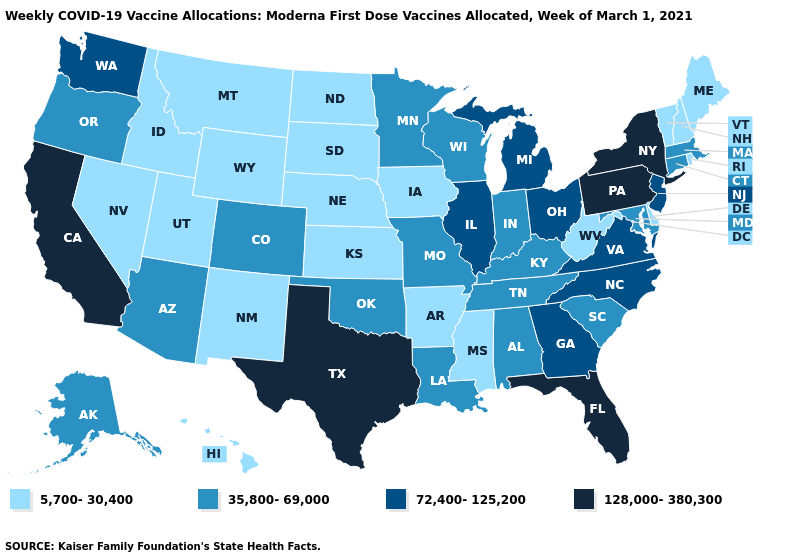What is the value of New York?
Short answer required. 128,000-380,300. What is the value of Rhode Island?
Concise answer only. 5,700-30,400. Does New Jersey have the same value as Washington?
Write a very short answer. Yes. What is the value of Ohio?
Give a very brief answer. 72,400-125,200. Which states have the lowest value in the USA?
Answer briefly. Arkansas, Delaware, Hawaii, Idaho, Iowa, Kansas, Maine, Mississippi, Montana, Nebraska, Nevada, New Hampshire, New Mexico, North Dakota, Rhode Island, South Dakota, Utah, Vermont, West Virginia, Wyoming. Does Pennsylvania have the highest value in the Northeast?
Quick response, please. Yes. Which states hav the highest value in the South?
Write a very short answer. Florida, Texas. What is the value of California?
Concise answer only. 128,000-380,300. Name the states that have a value in the range 72,400-125,200?
Give a very brief answer. Georgia, Illinois, Michigan, New Jersey, North Carolina, Ohio, Virginia, Washington. What is the highest value in the Northeast ?
Write a very short answer. 128,000-380,300. Does North Carolina have the same value as Wyoming?
Answer briefly. No. Name the states that have a value in the range 72,400-125,200?
Keep it brief. Georgia, Illinois, Michigan, New Jersey, North Carolina, Ohio, Virginia, Washington. What is the value of Pennsylvania?
Keep it brief. 128,000-380,300. Among the states that border North Carolina , does Virginia have the highest value?
Be succinct. Yes. Is the legend a continuous bar?
Quick response, please. No. 